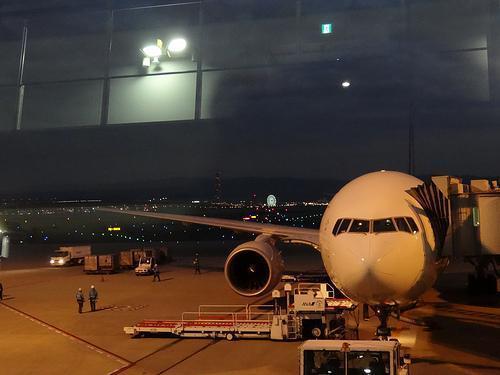How many men are there?
Give a very brief answer. 4. 